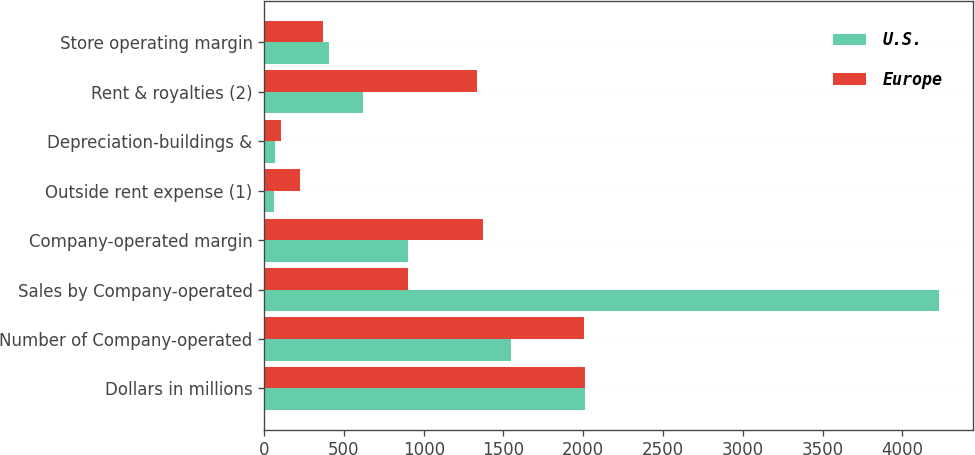Convert chart. <chart><loc_0><loc_0><loc_500><loc_500><stacked_bar_chart><ecel><fcel>Dollars in millions<fcel>Number of Company-operated<fcel>Sales by Company-operated<fcel>Company-operated margin<fcel>Outside rent expense (1)<fcel>Depreciation-buildings &<fcel>Rent & royalties (2)<fcel>Store operating margin<nl><fcel>U.S.<fcel>2010<fcel>1550<fcel>4229<fcel>902<fcel>60<fcel>65<fcel>619<fcel>408<nl><fcel>Europe<fcel>2010<fcel>2005<fcel>902<fcel>1373<fcel>223<fcel>105<fcel>1335<fcel>366<nl></chart> 